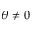<formula> <loc_0><loc_0><loc_500><loc_500>\theta \neq 0</formula> 